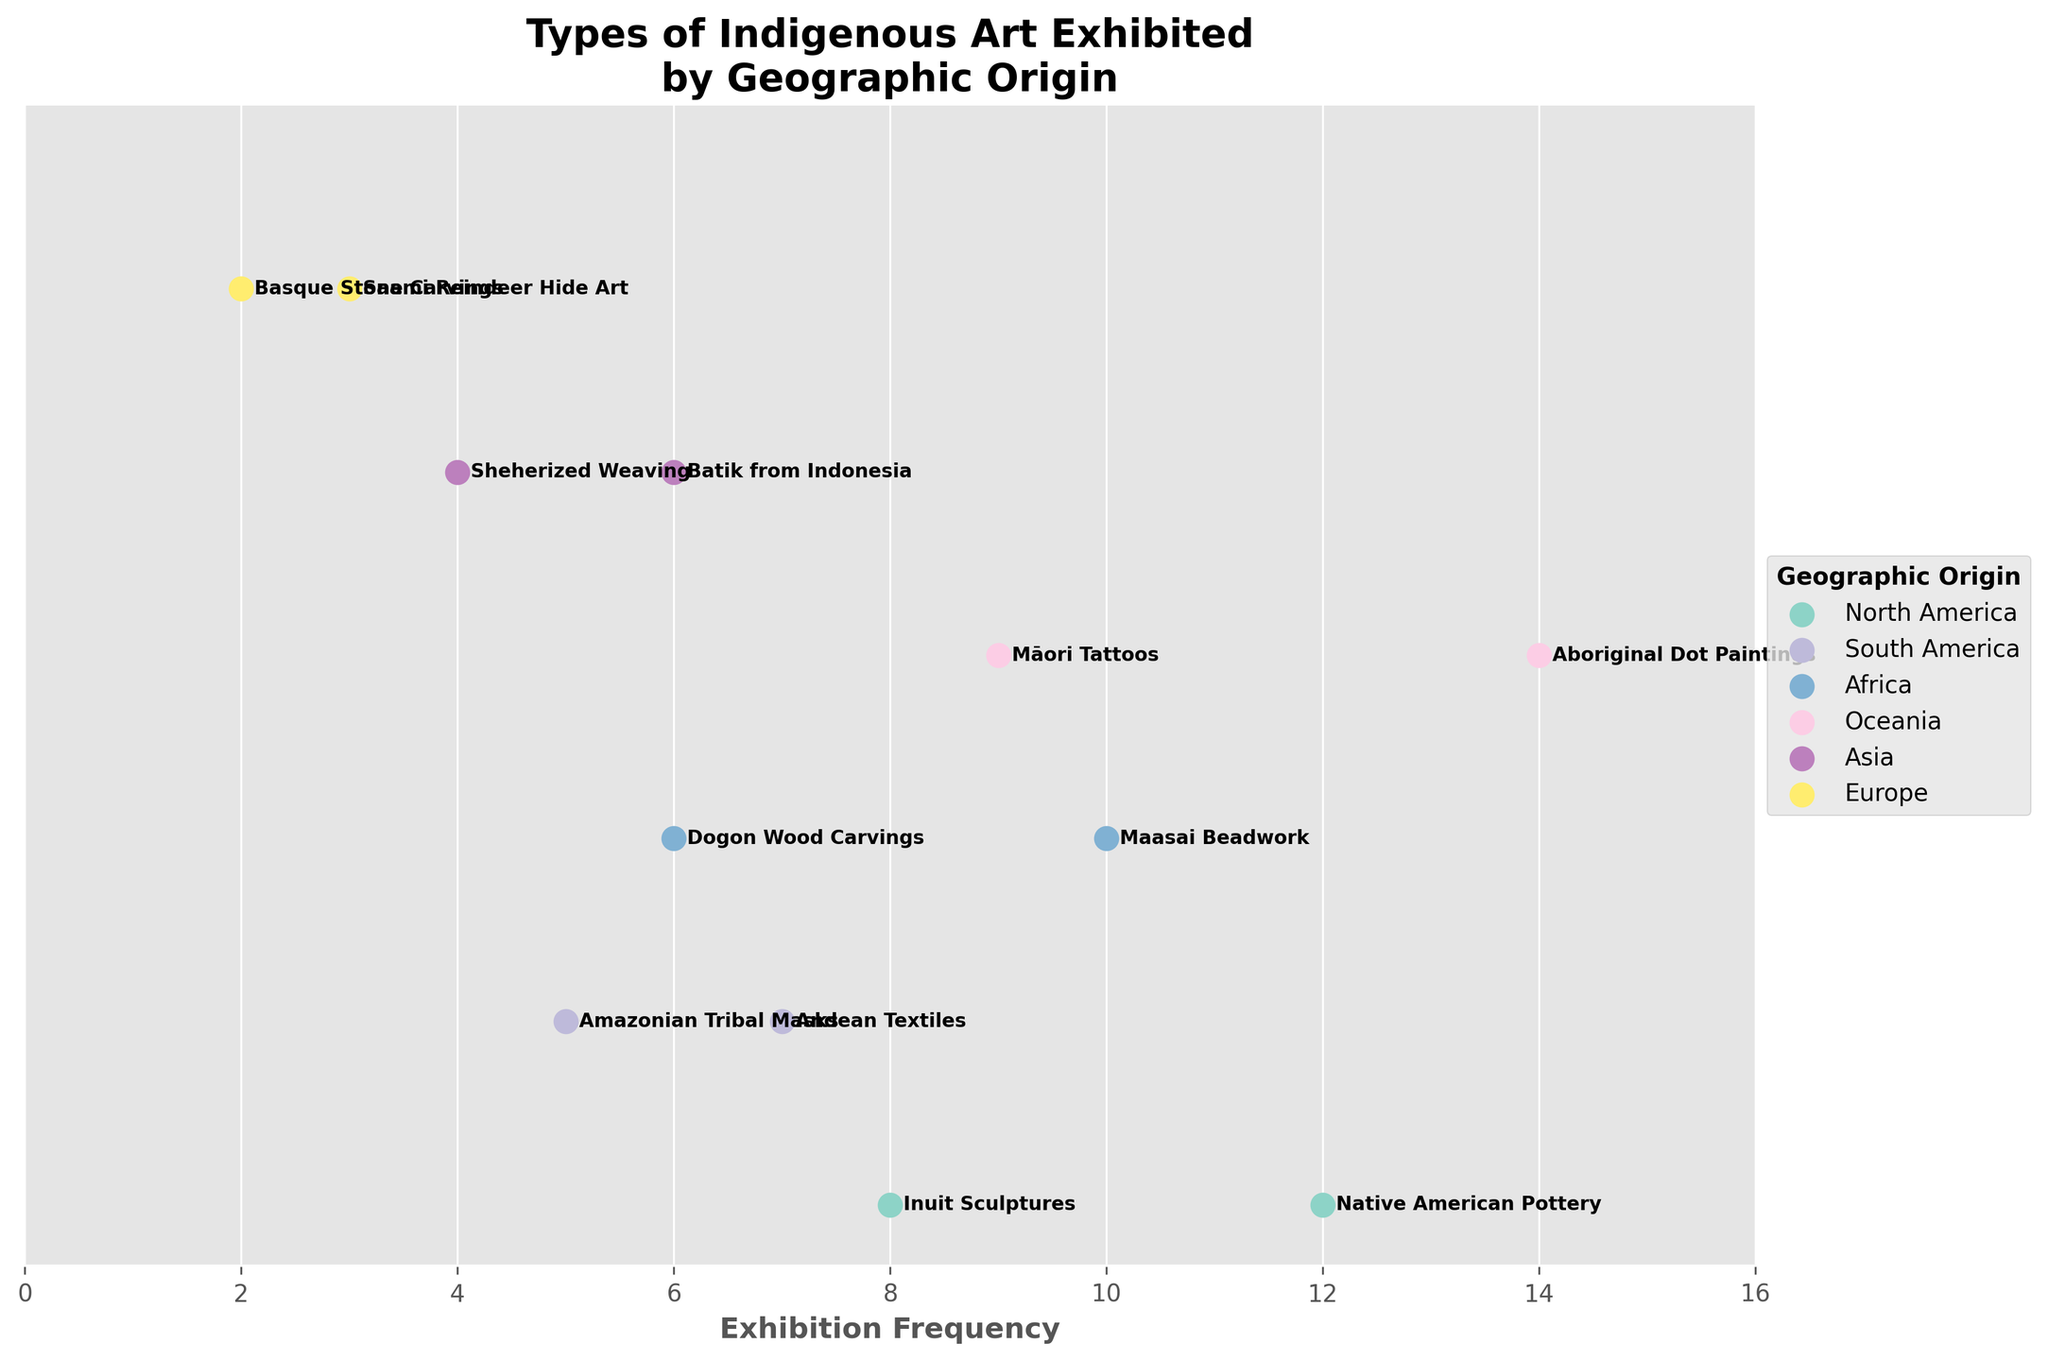What is the exhibition frequency for "Saami Reindeer Hide Art"? By looking at the plot, identify the dot labeled "Saami Reindeer Hide Art" and see the corresponding exhibition frequency on the x-axis.
Answer: 3 How many types of art from "Oceania" are exhibited? Count the number of dots located in the region representing "Oceania."
Answer: 2 Which geographic origin has the highest exhibition frequency? Compare all dots and find the highest value on the x-axis, then identify the corresponding geographic origin from the color legend.
Answer: Oceania (14) What is the difference in exhibition frequency between "Aboriginal Dot Paintings" and "Maasai Beadwork"? Locate "Aboriginal Dot Paintings" and "Maasai Beadwork" on the plot, note their frequencies, and calculate the difference: 14 - 10 = 4.
Answer: 4 Which type of art from "Asia" has the higher exhibition frequency? Identify the dots for "Sheherized Weaving" and "Batik from Indonesia" and compare their x-axis values.
Answer: Batik from Indonesia What is the sum of the exhibition frequencies of "North America" and "South America"? Add the exhibition frequencies for all art types in "North America" and "South America": (12 + 8 + 5 + 7) = 32.
Answer: 32 Which region has the smallest number of exhibited art types, and what are they? Determine the geographic origin with the least number of dots and identify the art types associated with it.
Answer: Europe (Saami Reindeer Hide Art, Basque Stone Carvings) 